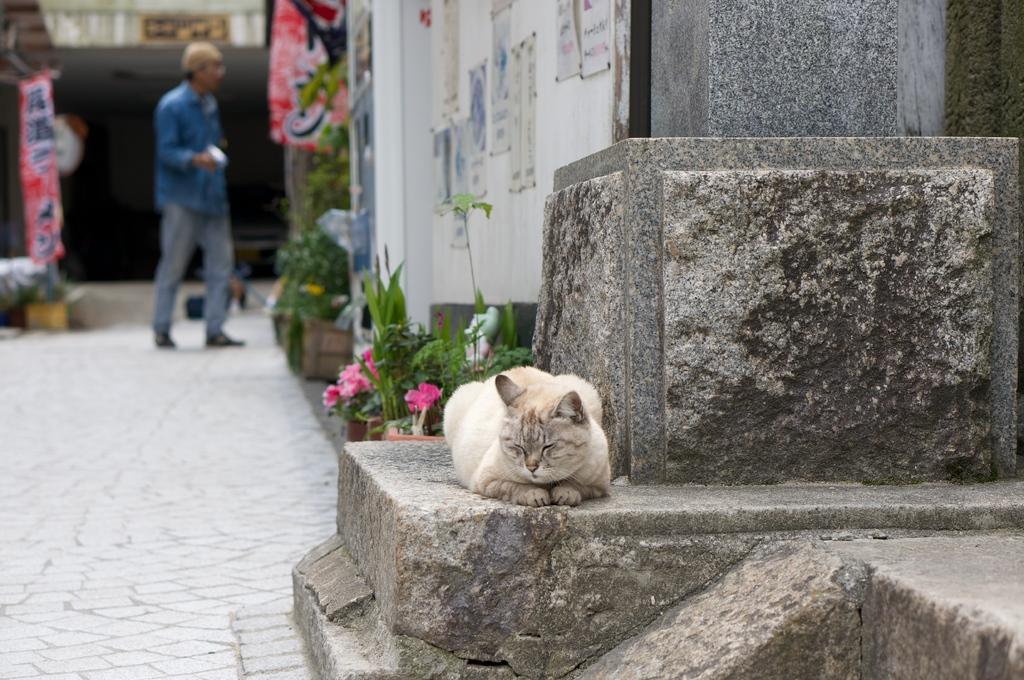What animal can be seen laying on the floor in the foreground of the image? There is a cat laying on the floor in the foreground of the image. What is the person in the background of the image doing? The person is standing on a path in the background of the image. What type of vegetation is present on the ground in the image? The ground contains plants. What structures can be seen in the background of the image? There are buildings visible in the background of the image. What additional decorative elements are present in the background of the image? Some banners are present in the background of the image. Can you see a rifle being used by the person in the background of the image? There is no rifle visible in the image; the person is simply standing on a path. Is there a tiger roaming around in the background of the image? There is no tiger present in the image; the only animal mentioned is the cat laying on the floor in the foreground. 